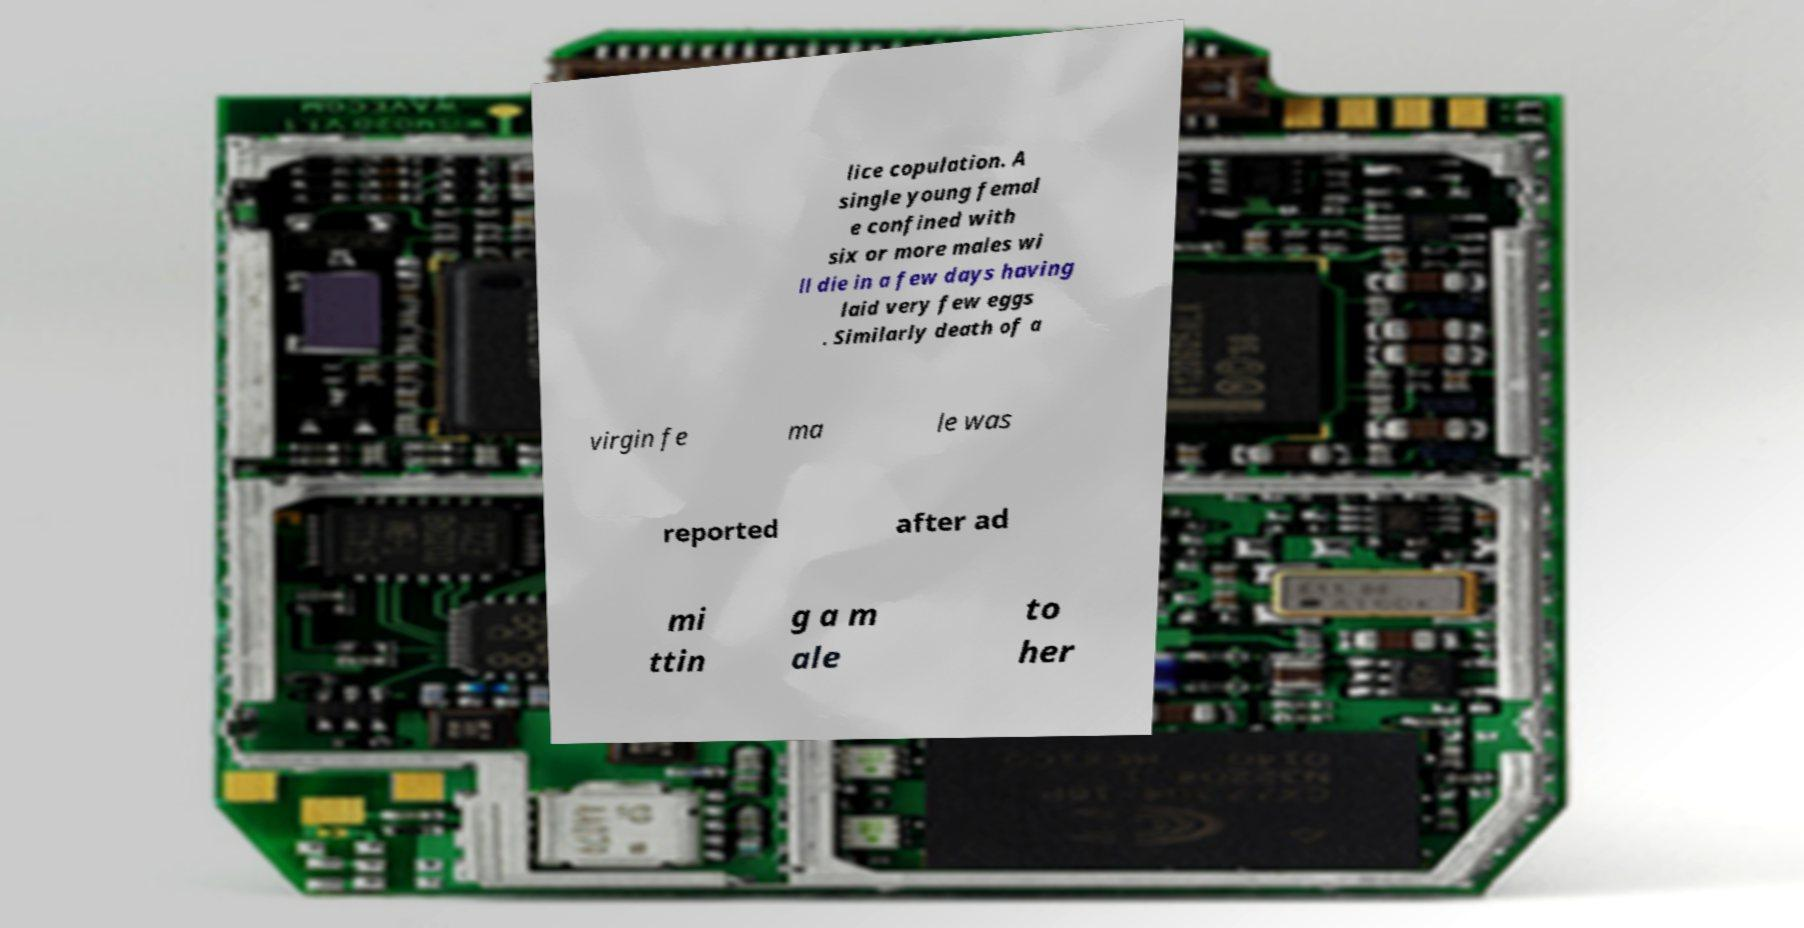What messages or text are displayed in this image? I need them in a readable, typed format. lice copulation. A single young femal e confined with six or more males wi ll die in a few days having laid very few eggs . Similarly death of a virgin fe ma le was reported after ad mi ttin g a m ale to her 